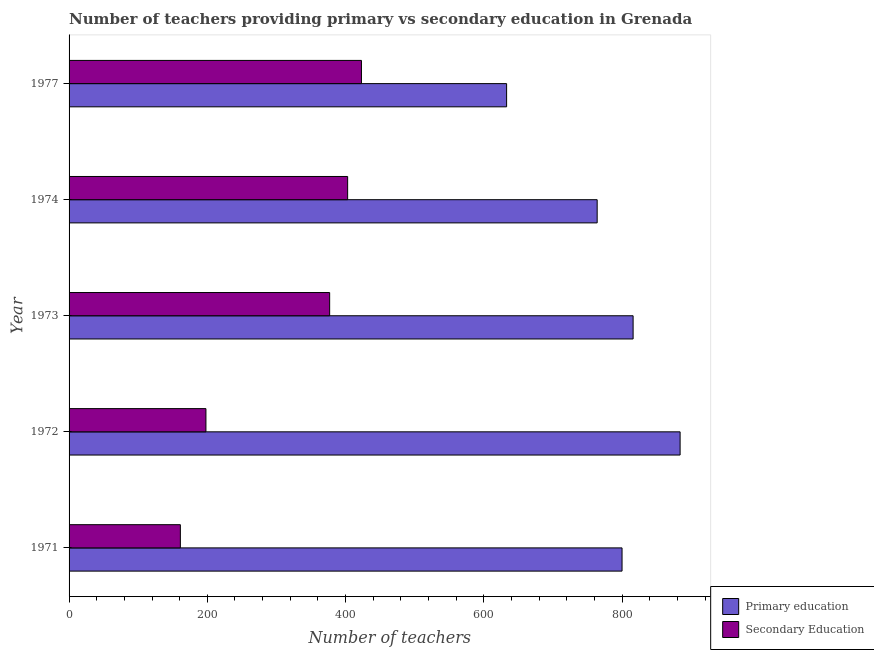How many different coloured bars are there?
Provide a short and direct response. 2. How many groups of bars are there?
Your answer should be compact. 5. In how many cases, is the number of bars for a given year not equal to the number of legend labels?
Give a very brief answer. 0. What is the number of secondary teachers in 1977?
Offer a terse response. 423. Across all years, what is the maximum number of secondary teachers?
Give a very brief answer. 423. Across all years, what is the minimum number of primary teachers?
Provide a succinct answer. 633. In which year was the number of secondary teachers minimum?
Give a very brief answer. 1971. What is the total number of secondary teachers in the graph?
Keep it short and to the point. 1562. What is the difference between the number of primary teachers in 1971 and that in 1972?
Give a very brief answer. -84. What is the difference between the number of secondary teachers in 1973 and the number of primary teachers in 1974?
Ensure brevity in your answer.  -387. What is the average number of primary teachers per year?
Make the answer very short. 779.4. In the year 1972, what is the difference between the number of secondary teachers and number of primary teachers?
Offer a terse response. -686. In how many years, is the number of secondary teachers greater than 400 ?
Make the answer very short. 2. What is the ratio of the number of secondary teachers in 1973 to that in 1977?
Your answer should be compact. 0.89. Is the number of secondary teachers in 1971 less than that in 1972?
Make the answer very short. Yes. What is the difference between the highest and the second highest number of secondary teachers?
Provide a short and direct response. 20. What is the difference between the highest and the lowest number of secondary teachers?
Your answer should be very brief. 262. In how many years, is the number of secondary teachers greater than the average number of secondary teachers taken over all years?
Ensure brevity in your answer.  3. Is the sum of the number of secondary teachers in 1972 and 1974 greater than the maximum number of primary teachers across all years?
Offer a terse response. No. What does the 1st bar from the top in 1973 represents?
Your answer should be compact. Secondary Education. What does the 2nd bar from the bottom in 1973 represents?
Your answer should be very brief. Secondary Education. How many bars are there?
Your answer should be very brief. 10. Are the values on the major ticks of X-axis written in scientific E-notation?
Make the answer very short. No. How many legend labels are there?
Keep it short and to the point. 2. What is the title of the graph?
Your response must be concise. Number of teachers providing primary vs secondary education in Grenada. What is the label or title of the X-axis?
Offer a very short reply. Number of teachers. What is the label or title of the Y-axis?
Your answer should be very brief. Year. What is the Number of teachers in Primary education in 1971?
Offer a terse response. 800. What is the Number of teachers of Secondary Education in 1971?
Give a very brief answer. 161. What is the Number of teachers of Primary education in 1972?
Provide a short and direct response. 884. What is the Number of teachers of Secondary Education in 1972?
Your answer should be very brief. 198. What is the Number of teachers in Primary education in 1973?
Keep it short and to the point. 816. What is the Number of teachers in Secondary Education in 1973?
Offer a very short reply. 377. What is the Number of teachers in Primary education in 1974?
Offer a terse response. 764. What is the Number of teachers of Secondary Education in 1974?
Offer a very short reply. 403. What is the Number of teachers of Primary education in 1977?
Ensure brevity in your answer.  633. What is the Number of teachers of Secondary Education in 1977?
Give a very brief answer. 423. Across all years, what is the maximum Number of teachers of Primary education?
Provide a short and direct response. 884. Across all years, what is the maximum Number of teachers of Secondary Education?
Your answer should be compact. 423. Across all years, what is the minimum Number of teachers of Primary education?
Keep it short and to the point. 633. Across all years, what is the minimum Number of teachers in Secondary Education?
Your answer should be compact. 161. What is the total Number of teachers in Primary education in the graph?
Your answer should be very brief. 3897. What is the total Number of teachers of Secondary Education in the graph?
Provide a succinct answer. 1562. What is the difference between the Number of teachers in Primary education in 1971 and that in 1972?
Make the answer very short. -84. What is the difference between the Number of teachers of Secondary Education in 1971 and that in 1972?
Keep it short and to the point. -37. What is the difference between the Number of teachers of Secondary Education in 1971 and that in 1973?
Your response must be concise. -216. What is the difference between the Number of teachers in Secondary Education in 1971 and that in 1974?
Ensure brevity in your answer.  -242. What is the difference between the Number of teachers of Primary education in 1971 and that in 1977?
Offer a terse response. 167. What is the difference between the Number of teachers of Secondary Education in 1971 and that in 1977?
Provide a succinct answer. -262. What is the difference between the Number of teachers in Primary education in 1972 and that in 1973?
Make the answer very short. 68. What is the difference between the Number of teachers in Secondary Education in 1972 and that in 1973?
Ensure brevity in your answer.  -179. What is the difference between the Number of teachers of Primary education in 1972 and that in 1974?
Keep it short and to the point. 120. What is the difference between the Number of teachers of Secondary Education in 1972 and that in 1974?
Give a very brief answer. -205. What is the difference between the Number of teachers in Primary education in 1972 and that in 1977?
Provide a succinct answer. 251. What is the difference between the Number of teachers in Secondary Education in 1972 and that in 1977?
Offer a very short reply. -225. What is the difference between the Number of teachers of Primary education in 1973 and that in 1974?
Make the answer very short. 52. What is the difference between the Number of teachers of Primary education in 1973 and that in 1977?
Make the answer very short. 183. What is the difference between the Number of teachers in Secondary Education in 1973 and that in 1977?
Provide a short and direct response. -46. What is the difference between the Number of teachers of Primary education in 1974 and that in 1977?
Offer a very short reply. 131. What is the difference between the Number of teachers in Secondary Education in 1974 and that in 1977?
Your answer should be compact. -20. What is the difference between the Number of teachers of Primary education in 1971 and the Number of teachers of Secondary Education in 1972?
Make the answer very short. 602. What is the difference between the Number of teachers of Primary education in 1971 and the Number of teachers of Secondary Education in 1973?
Your answer should be very brief. 423. What is the difference between the Number of teachers of Primary education in 1971 and the Number of teachers of Secondary Education in 1974?
Keep it short and to the point. 397. What is the difference between the Number of teachers in Primary education in 1971 and the Number of teachers in Secondary Education in 1977?
Give a very brief answer. 377. What is the difference between the Number of teachers of Primary education in 1972 and the Number of teachers of Secondary Education in 1973?
Keep it short and to the point. 507. What is the difference between the Number of teachers in Primary education in 1972 and the Number of teachers in Secondary Education in 1974?
Your answer should be very brief. 481. What is the difference between the Number of teachers of Primary education in 1972 and the Number of teachers of Secondary Education in 1977?
Offer a very short reply. 461. What is the difference between the Number of teachers in Primary education in 1973 and the Number of teachers in Secondary Education in 1974?
Your response must be concise. 413. What is the difference between the Number of teachers in Primary education in 1973 and the Number of teachers in Secondary Education in 1977?
Provide a short and direct response. 393. What is the difference between the Number of teachers in Primary education in 1974 and the Number of teachers in Secondary Education in 1977?
Your answer should be compact. 341. What is the average Number of teachers of Primary education per year?
Your answer should be very brief. 779.4. What is the average Number of teachers of Secondary Education per year?
Offer a terse response. 312.4. In the year 1971, what is the difference between the Number of teachers of Primary education and Number of teachers of Secondary Education?
Make the answer very short. 639. In the year 1972, what is the difference between the Number of teachers of Primary education and Number of teachers of Secondary Education?
Make the answer very short. 686. In the year 1973, what is the difference between the Number of teachers of Primary education and Number of teachers of Secondary Education?
Your answer should be compact. 439. In the year 1974, what is the difference between the Number of teachers in Primary education and Number of teachers in Secondary Education?
Provide a short and direct response. 361. In the year 1977, what is the difference between the Number of teachers of Primary education and Number of teachers of Secondary Education?
Your answer should be very brief. 210. What is the ratio of the Number of teachers in Primary education in 1971 to that in 1972?
Provide a succinct answer. 0.91. What is the ratio of the Number of teachers of Secondary Education in 1971 to that in 1972?
Your response must be concise. 0.81. What is the ratio of the Number of teachers of Primary education in 1971 to that in 1973?
Give a very brief answer. 0.98. What is the ratio of the Number of teachers in Secondary Education in 1971 to that in 1973?
Provide a succinct answer. 0.43. What is the ratio of the Number of teachers of Primary education in 1971 to that in 1974?
Offer a terse response. 1.05. What is the ratio of the Number of teachers of Secondary Education in 1971 to that in 1974?
Keep it short and to the point. 0.4. What is the ratio of the Number of teachers in Primary education in 1971 to that in 1977?
Your answer should be very brief. 1.26. What is the ratio of the Number of teachers in Secondary Education in 1971 to that in 1977?
Offer a very short reply. 0.38. What is the ratio of the Number of teachers in Secondary Education in 1972 to that in 1973?
Provide a short and direct response. 0.53. What is the ratio of the Number of teachers in Primary education in 1972 to that in 1974?
Your answer should be compact. 1.16. What is the ratio of the Number of teachers in Secondary Education in 1972 to that in 1974?
Provide a succinct answer. 0.49. What is the ratio of the Number of teachers in Primary education in 1972 to that in 1977?
Provide a succinct answer. 1.4. What is the ratio of the Number of teachers of Secondary Education in 1972 to that in 1977?
Your response must be concise. 0.47. What is the ratio of the Number of teachers of Primary education in 1973 to that in 1974?
Give a very brief answer. 1.07. What is the ratio of the Number of teachers in Secondary Education in 1973 to that in 1974?
Ensure brevity in your answer.  0.94. What is the ratio of the Number of teachers of Primary education in 1973 to that in 1977?
Provide a succinct answer. 1.29. What is the ratio of the Number of teachers in Secondary Education in 1973 to that in 1977?
Your response must be concise. 0.89. What is the ratio of the Number of teachers of Primary education in 1974 to that in 1977?
Your answer should be compact. 1.21. What is the ratio of the Number of teachers of Secondary Education in 1974 to that in 1977?
Your answer should be compact. 0.95. What is the difference between the highest and the lowest Number of teachers of Primary education?
Your answer should be very brief. 251. What is the difference between the highest and the lowest Number of teachers in Secondary Education?
Give a very brief answer. 262. 